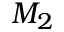<formula> <loc_0><loc_0><loc_500><loc_500>M _ { 2 }</formula> 